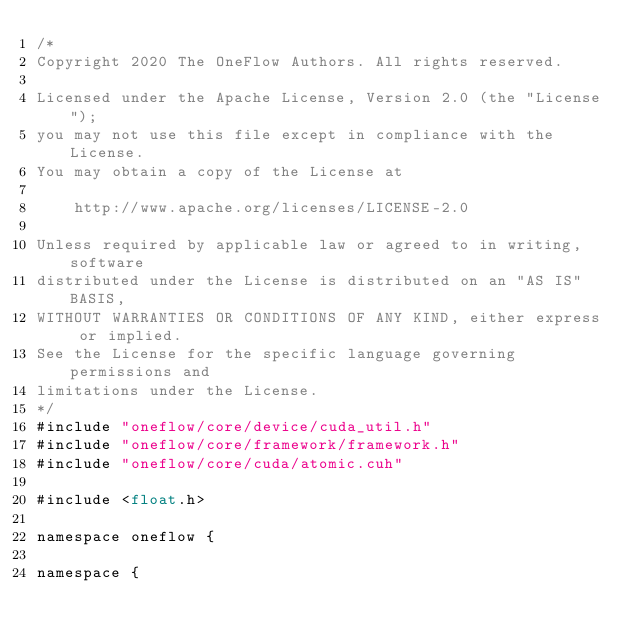<code> <loc_0><loc_0><loc_500><loc_500><_Cuda_>/*
Copyright 2020 The OneFlow Authors. All rights reserved.

Licensed under the Apache License, Version 2.0 (the "License");
you may not use this file except in compliance with the License.
You may obtain a copy of the License at

    http://www.apache.org/licenses/LICENSE-2.0

Unless required by applicable law or agreed to in writing, software
distributed under the License is distributed on an "AS IS" BASIS,
WITHOUT WARRANTIES OR CONDITIONS OF ANY KIND, either express or implied.
See the License for the specific language governing permissions and
limitations under the License.
*/
#include "oneflow/core/device/cuda_util.h"
#include "oneflow/core/framework/framework.h"
#include "oneflow/core/cuda/atomic.cuh"

#include <float.h>

namespace oneflow {

namespace {
</code> 